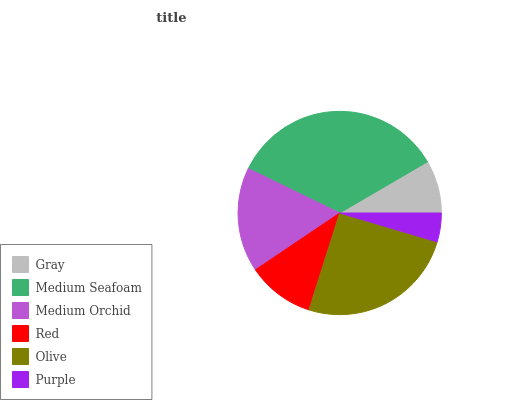Is Purple the minimum?
Answer yes or no. Yes. Is Medium Seafoam the maximum?
Answer yes or no. Yes. Is Medium Orchid the minimum?
Answer yes or no. No. Is Medium Orchid the maximum?
Answer yes or no. No. Is Medium Seafoam greater than Medium Orchid?
Answer yes or no. Yes. Is Medium Orchid less than Medium Seafoam?
Answer yes or no. Yes. Is Medium Orchid greater than Medium Seafoam?
Answer yes or no. No. Is Medium Seafoam less than Medium Orchid?
Answer yes or no. No. Is Medium Orchid the high median?
Answer yes or no. Yes. Is Red the low median?
Answer yes or no. Yes. Is Olive the high median?
Answer yes or no. No. Is Medium Seafoam the low median?
Answer yes or no. No. 